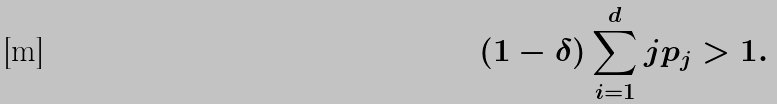Convert formula to latex. <formula><loc_0><loc_0><loc_500><loc_500>( 1 - \delta ) \sum _ { i = 1 } ^ { d } j p _ { j } > 1 .</formula> 